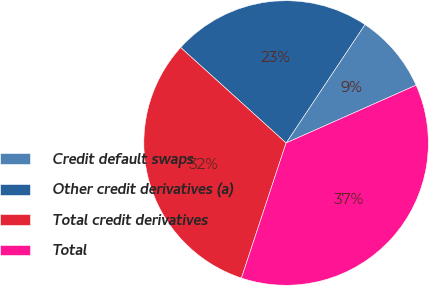Convert chart. <chart><loc_0><loc_0><loc_500><loc_500><pie_chart><fcel>Credit default swaps<fcel>Other credit derivatives (a)<fcel>Total credit derivatives<fcel>Total<nl><fcel>8.99%<fcel>22.64%<fcel>31.63%<fcel>36.74%<nl></chart> 